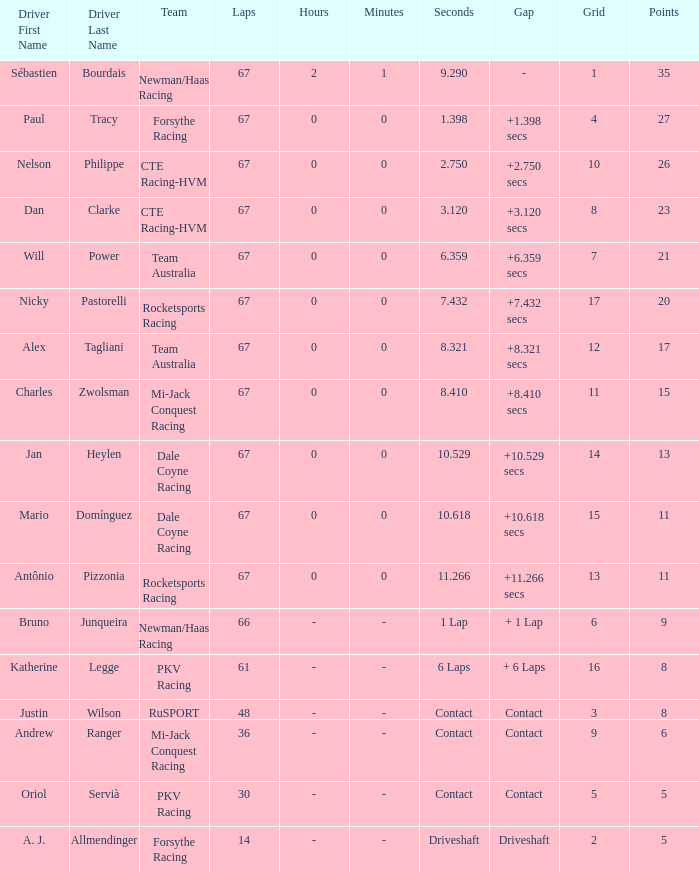What was time/retired with less than 67 laps and 6 points? Contact. 